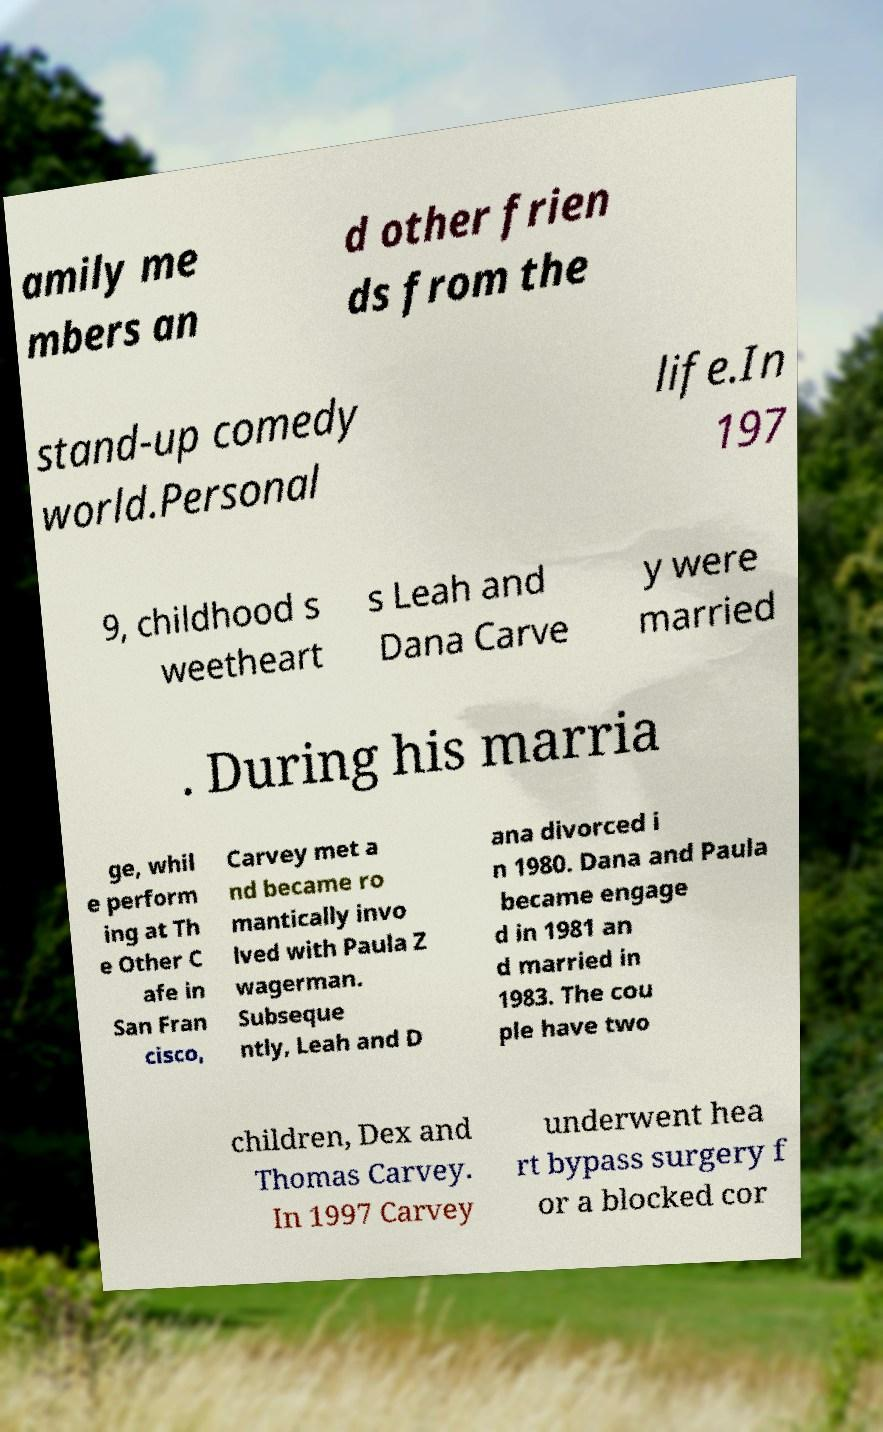Could you assist in decoding the text presented in this image and type it out clearly? amily me mbers an d other frien ds from the stand-up comedy world.Personal life.In 197 9, childhood s weetheart s Leah and Dana Carve y were married . During his marria ge, whil e perform ing at Th e Other C afe in San Fran cisco, Carvey met a nd became ro mantically invo lved with Paula Z wagerman. Subseque ntly, Leah and D ana divorced i n 1980. Dana and Paula became engage d in 1981 an d married in 1983. The cou ple have two children, Dex and Thomas Carvey. In 1997 Carvey underwent hea rt bypass surgery f or a blocked cor 